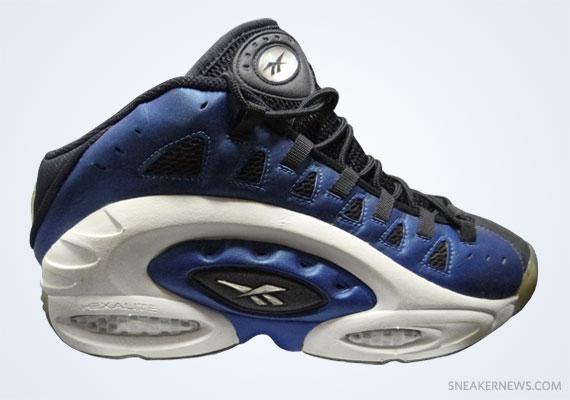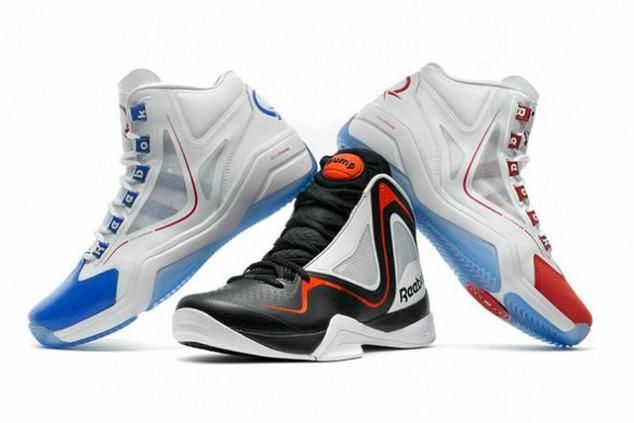The first image is the image on the left, the second image is the image on the right. Examine the images to the left and right. Is the description "There are fewer than four shoes depicted." accurate? Answer yes or no. No. The first image is the image on the left, the second image is the image on the right. Analyze the images presented: Is the assertion "The left image contains a single right-facing blue sneaker, and the right image includes a shoe sole facing the camera." valid? Answer yes or no. No. 